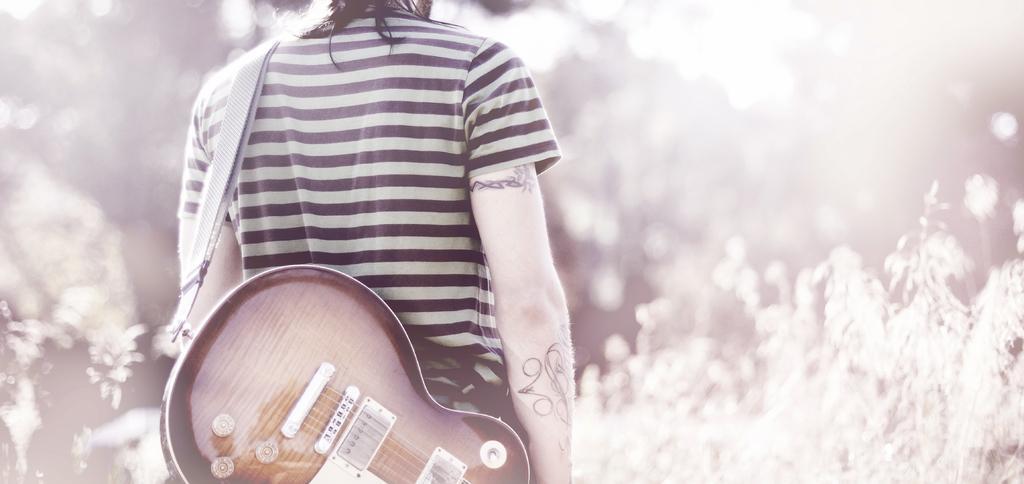In one or two sentences, can you explain what this image depicts? A person is standing and holding a guitar. 